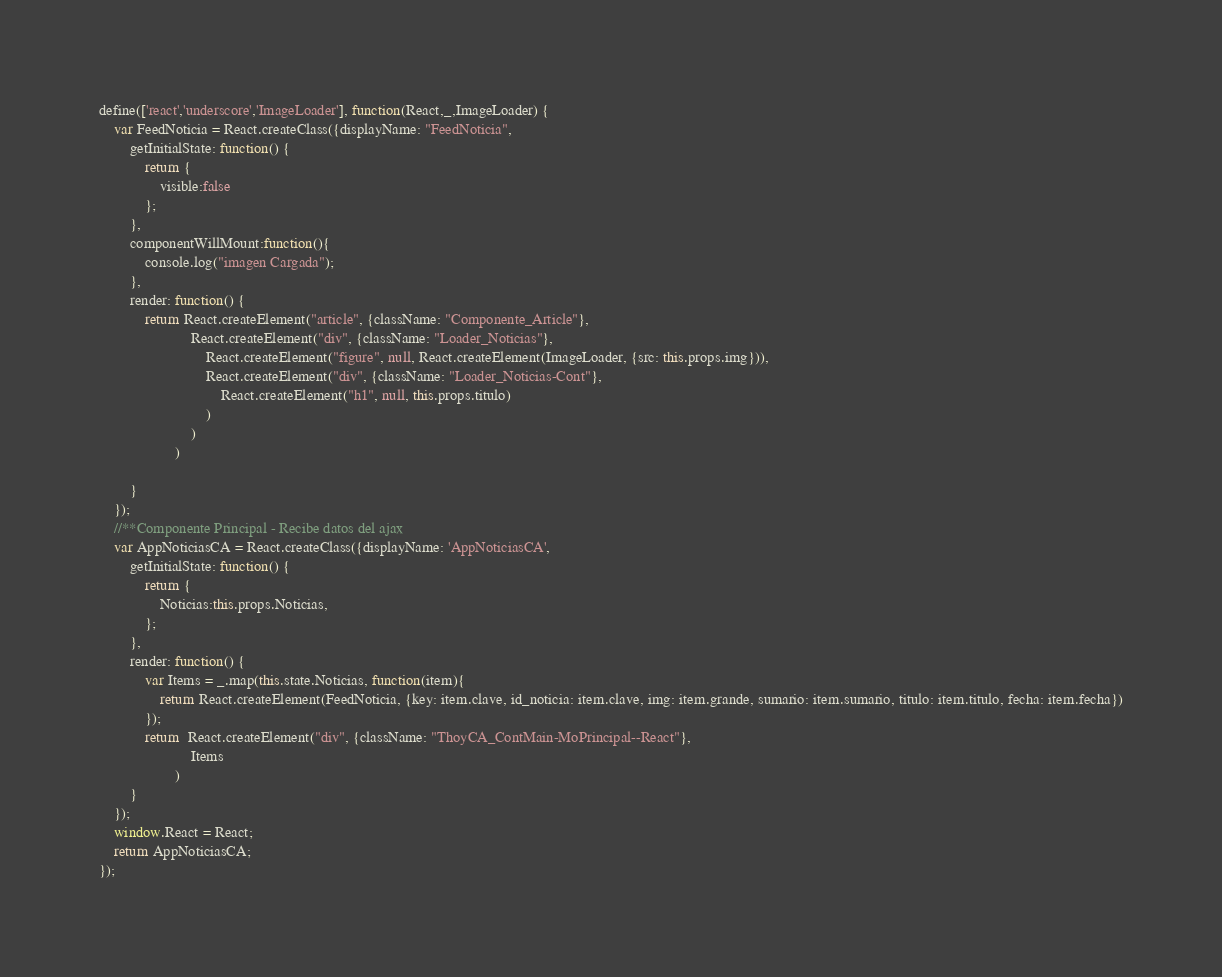<code> <loc_0><loc_0><loc_500><loc_500><_JavaScript_>define(['react','underscore','ImageLoader'], function(React,_,ImageLoader) {
	var FeedNoticia = React.createClass({displayName: "FeedNoticia",
		getInitialState: function() {
			return {
				visible:false 
			};
		},
		componentWillMount:function(){
			console.log("imagen Cargada");
		},
		render: function() {
			return React.createElement("article", {className: "Componente_Article"}, 
						React.createElement("div", {className: "Loader_Noticias"}, 
		                    React.createElement("figure", null, React.createElement(ImageLoader, {src: this.props.img})), 
		                    React.createElement("div", {className: "Loader_Noticias-Cont"}, 
		                        React.createElement("h1", null, this.props.titulo)
		                    )
		                )
	            	)
			
		}
	});
	//**Componente Principal - Recibe datos del ajax
	var AppNoticiasCA = React.createClass({displayName: 'AppNoticiasCA',
		getInitialState: function() {
			return {
				Noticias:this.props.Noticias, 
			};
		},
		render: function() {
			var Items = _.map(this.state.Noticias, function(item){ 
				return React.createElement(FeedNoticia, {key: item.clave, id_noticia: item.clave, img: item.grande, sumario: item.sumario, titulo: item.titulo, fecha: item.fecha})
			});	
			return  React.createElement("div", {className: "ThoyCA_ContMain-MoPrincipal--React"}, 
						Items
		 			)
		}
	});
	window.React = React;
    return AppNoticiasCA;
});</code> 